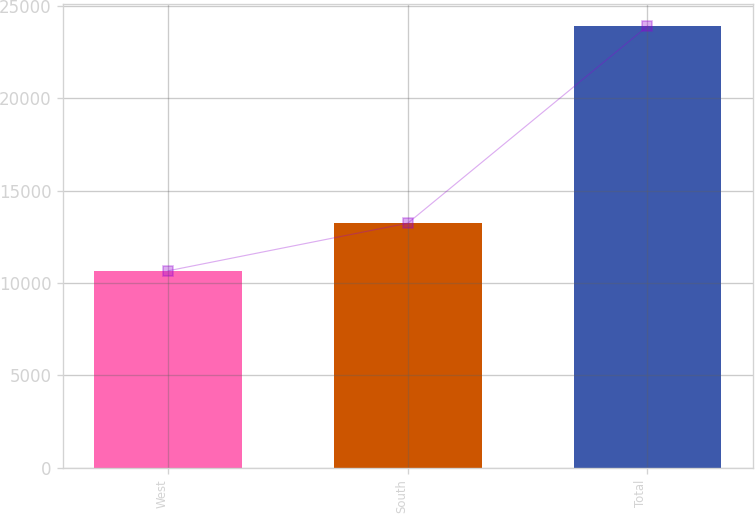Convert chart to OTSL. <chart><loc_0><loc_0><loc_500><loc_500><bar_chart><fcel>West<fcel>South<fcel>Total<nl><fcel>10666<fcel>13246<fcel>23912<nl></chart> 